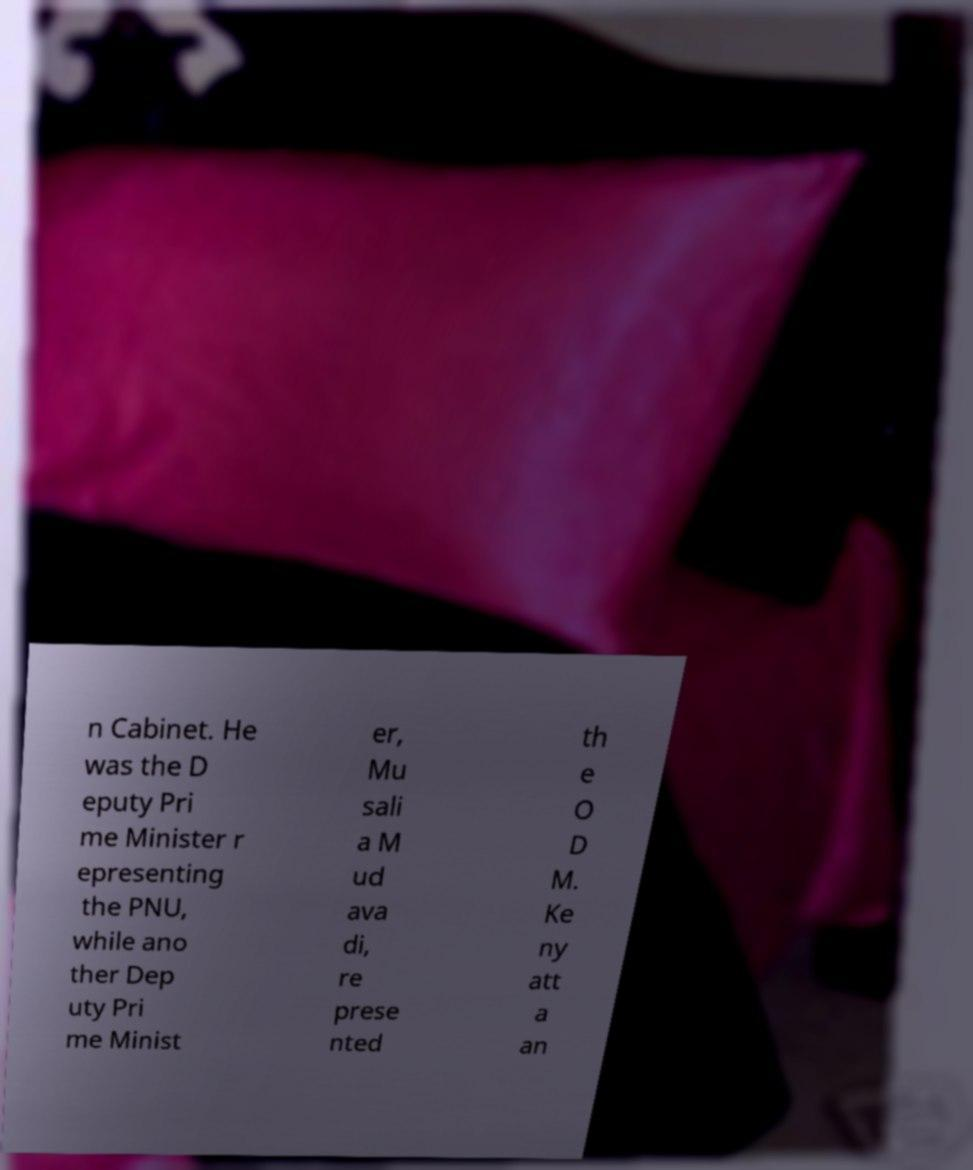What messages or text are displayed in this image? I need them in a readable, typed format. n Cabinet. He was the D eputy Pri me Minister r epresenting the PNU, while ano ther Dep uty Pri me Minist er, Mu sali a M ud ava di, re prese nted th e O D M. Ke ny att a an 